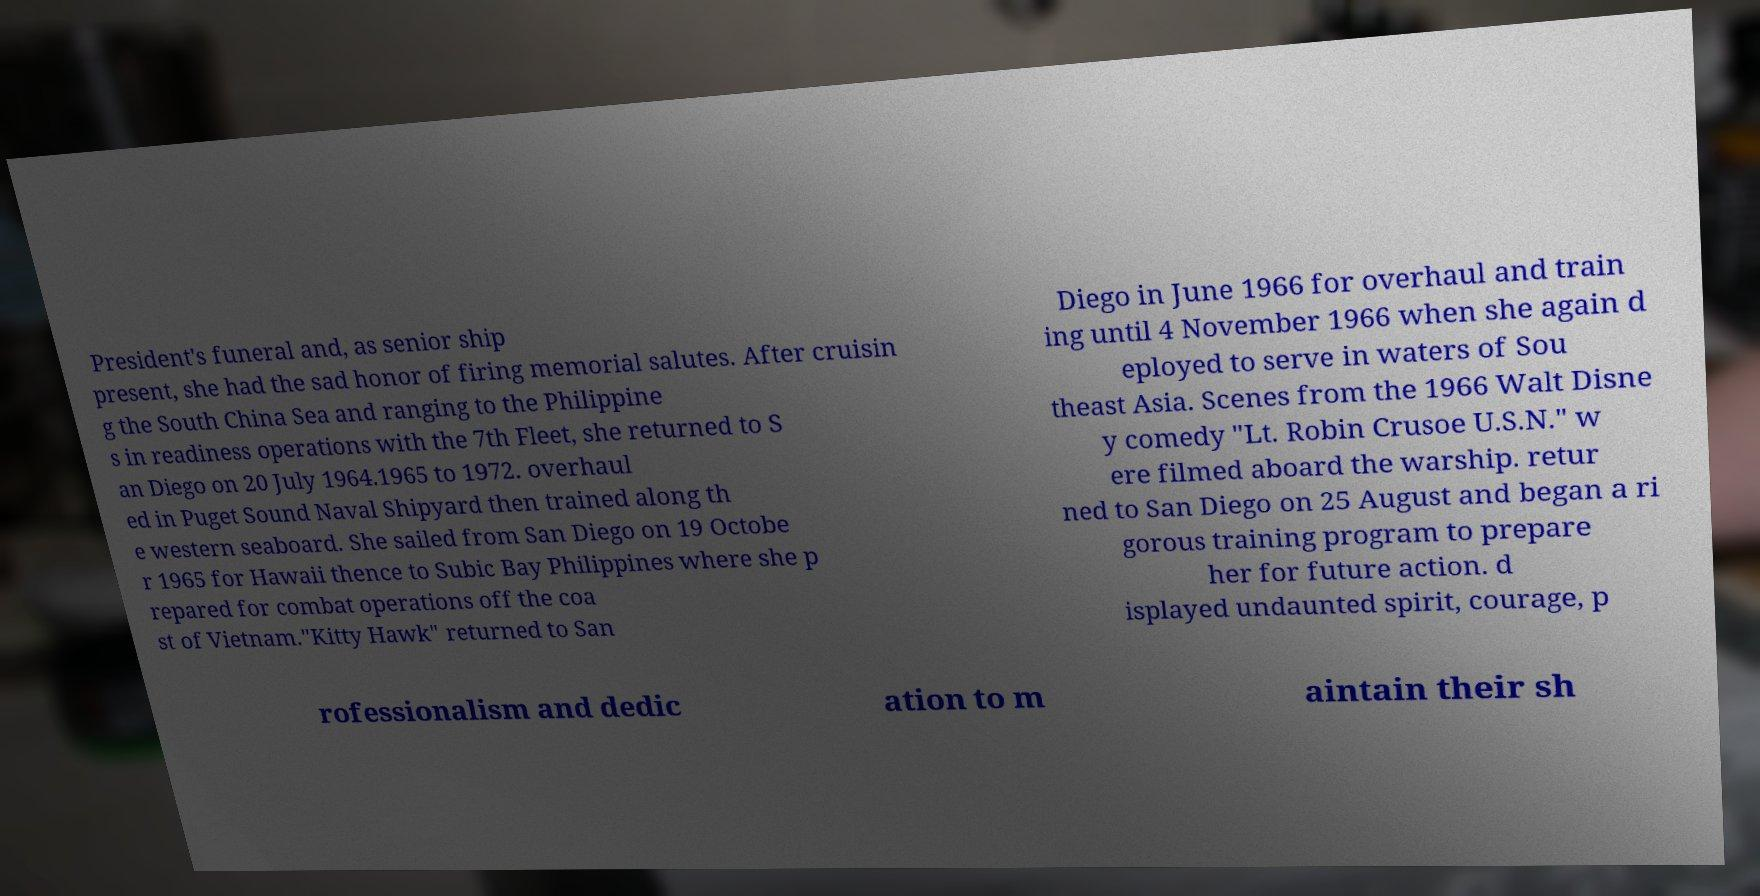Please read and relay the text visible in this image. What does it say? President's funeral and, as senior ship present, she had the sad honor of firing memorial salutes. After cruisin g the South China Sea and ranging to the Philippine s in readiness operations with the 7th Fleet, she returned to S an Diego on 20 July 1964.1965 to 1972. overhaul ed in Puget Sound Naval Shipyard then trained along th e western seaboard. She sailed from San Diego on 19 Octobe r 1965 for Hawaii thence to Subic Bay Philippines where she p repared for combat operations off the coa st of Vietnam."Kitty Hawk" returned to San Diego in June 1966 for overhaul and train ing until 4 November 1966 when she again d eployed to serve in waters of Sou theast Asia. Scenes from the 1966 Walt Disne y comedy "Lt. Robin Crusoe U.S.N." w ere filmed aboard the warship. retur ned to San Diego on 25 August and began a ri gorous training program to prepare her for future action. d isplayed undaunted spirit, courage, p rofessionalism and dedic ation to m aintain their sh 